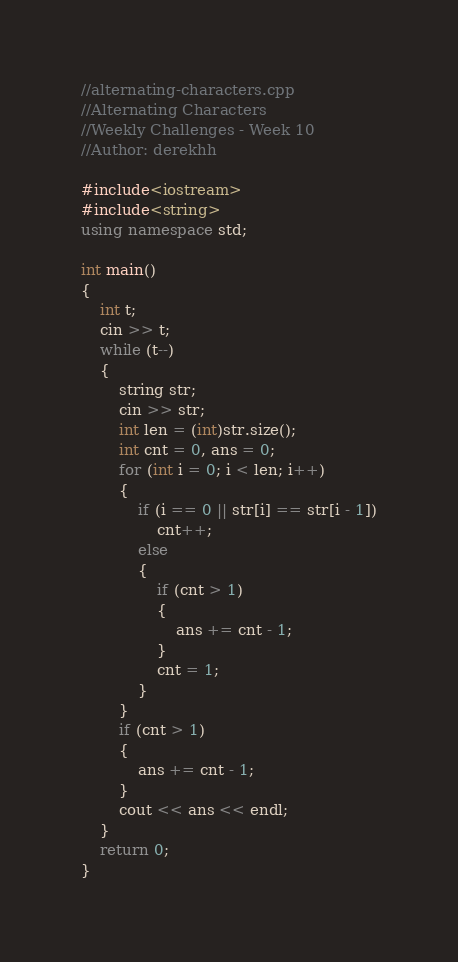<code> <loc_0><loc_0><loc_500><loc_500><_C++_>//alternating-characters.cpp
//Alternating Characters
//Weekly Challenges - Week 10
//Author: derekhh

#include<iostream>
#include<string>
using namespace std;

int main()
{
	int t;
	cin >> t;
	while (t--)
	{
		string str;
		cin >> str;
		int len = (int)str.size();
		int cnt = 0, ans = 0;
		for (int i = 0; i < len; i++)
		{
			if (i == 0 || str[i] == str[i - 1])
				cnt++;
			else
			{
				if (cnt > 1)
				{
					ans += cnt - 1;
				}
				cnt = 1;
			}
		}
		if (cnt > 1)
		{
			ans += cnt - 1;
		}
		cout << ans << endl;
	}
	return 0;
}</code> 